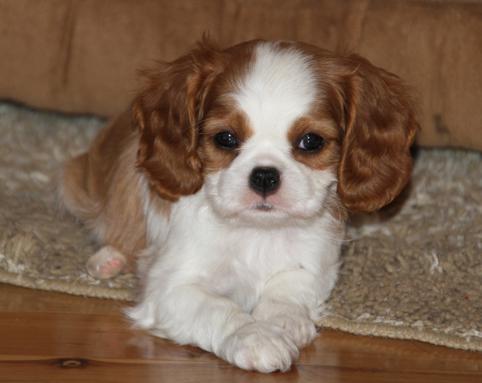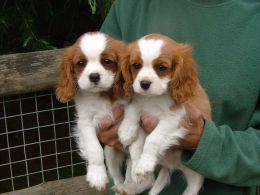The first image is the image on the left, the second image is the image on the right. Evaluate the accuracy of this statement regarding the images: "Human hands hold at least one puppy in one image.". Is it true? Answer yes or no. Yes. The first image is the image on the left, the second image is the image on the right. Analyze the images presented: Is the assertion "Someone is holding up at least one of the puppies." valid? Answer yes or no. Yes. 